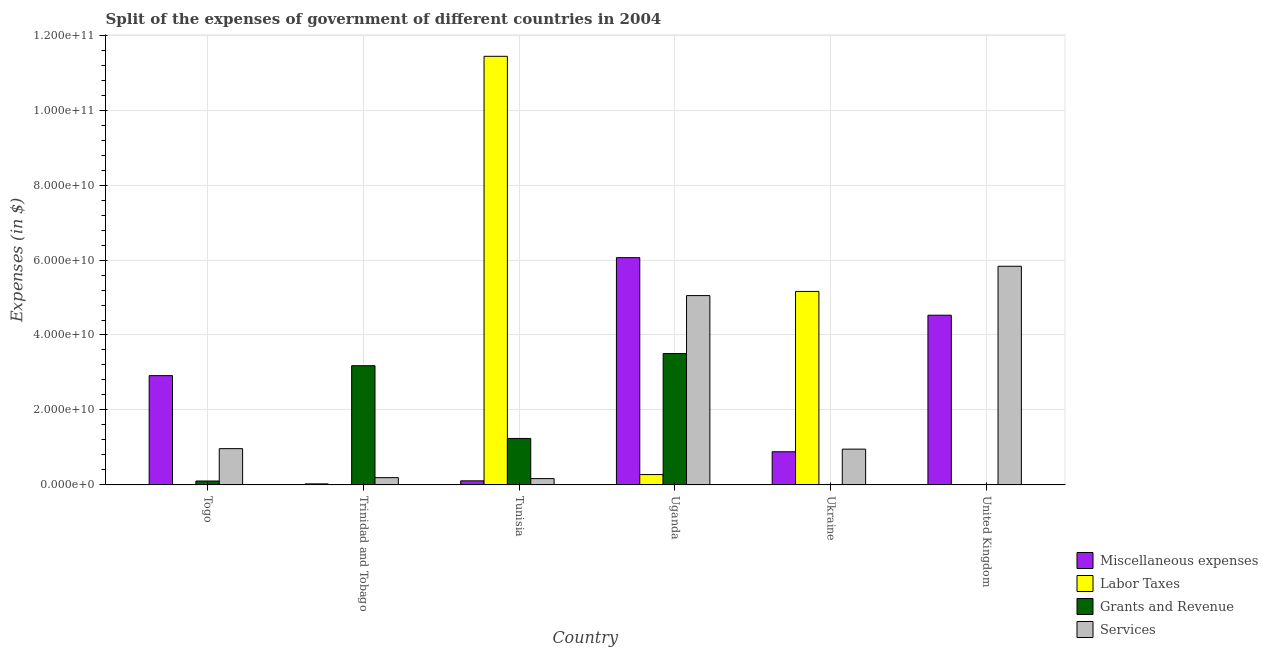How many groups of bars are there?
Offer a very short reply. 6. Are the number of bars per tick equal to the number of legend labels?
Ensure brevity in your answer.  Yes. What is the label of the 6th group of bars from the left?
Your response must be concise. United Kingdom. In how many cases, is the number of bars for a given country not equal to the number of legend labels?
Give a very brief answer. 0. What is the amount spent on grants and revenue in Uganda?
Give a very brief answer. 3.51e+1. Across all countries, what is the maximum amount spent on labor taxes?
Give a very brief answer. 1.14e+11. Across all countries, what is the minimum amount spent on grants and revenue?
Keep it short and to the point. 6.00e+06. In which country was the amount spent on services maximum?
Ensure brevity in your answer.  United Kingdom. In which country was the amount spent on miscellaneous expenses minimum?
Your response must be concise. Trinidad and Tobago. What is the total amount spent on grants and revenue in the graph?
Ensure brevity in your answer.  8.04e+1. What is the difference between the amount spent on labor taxes in Trinidad and Tobago and that in Uganda?
Your answer should be very brief. -2.71e+09. What is the difference between the amount spent on grants and revenue in Uganda and the amount spent on labor taxes in Togo?
Keep it short and to the point. 3.50e+1. What is the average amount spent on services per country?
Offer a very short reply. 2.19e+1. What is the difference between the amount spent on labor taxes and amount spent on miscellaneous expenses in Togo?
Keep it short and to the point. -2.92e+1. In how many countries, is the amount spent on labor taxes greater than 116000000000 $?
Your response must be concise. 0. What is the ratio of the amount spent on grants and revenue in Trinidad and Tobago to that in Tunisia?
Your response must be concise. 2.57. Is the difference between the amount spent on labor taxes in Togo and Tunisia greater than the difference between the amount spent on services in Togo and Tunisia?
Offer a terse response. No. What is the difference between the highest and the second highest amount spent on labor taxes?
Provide a short and direct response. 6.27e+1. What is the difference between the highest and the lowest amount spent on grants and revenue?
Provide a short and direct response. 3.50e+1. Is it the case that in every country, the sum of the amount spent on labor taxes and amount spent on grants and revenue is greater than the sum of amount spent on services and amount spent on miscellaneous expenses?
Give a very brief answer. No. What does the 1st bar from the left in United Kingdom represents?
Offer a terse response. Miscellaneous expenses. What does the 3rd bar from the right in United Kingdom represents?
Your answer should be compact. Labor Taxes. Is it the case that in every country, the sum of the amount spent on miscellaneous expenses and amount spent on labor taxes is greater than the amount spent on grants and revenue?
Your answer should be compact. No. How many countries are there in the graph?
Offer a terse response. 6. What is the difference between two consecutive major ticks on the Y-axis?
Offer a very short reply. 2.00e+1. Are the values on the major ticks of Y-axis written in scientific E-notation?
Provide a succinct answer. Yes. Does the graph contain any zero values?
Your response must be concise. No. Does the graph contain grids?
Keep it short and to the point. Yes. How are the legend labels stacked?
Offer a very short reply. Vertical. What is the title of the graph?
Your answer should be very brief. Split of the expenses of government of different countries in 2004. What is the label or title of the X-axis?
Offer a very short reply. Country. What is the label or title of the Y-axis?
Offer a very short reply. Expenses (in $). What is the Expenses (in $) in Miscellaneous expenses in Togo?
Your response must be concise. 2.92e+1. What is the Expenses (in $) of Labor Taxes in Togo?
Offer a very short reply. 2.50e+06. What is the Expenses (in $) of Grants and Revenue in Togo?
Provide a short and direct response. 1.04e+09. What is the Expenses (in $) in Services in Togo?
Provide a succinct answer. 9.67e+09. What is the Expenses (in $) in Miscellaneous expenses in Trinidad and Tobago?
Ensure brevity in your answer.  2.71e+08. What is the Expenses (in $) of Labor Taxes in Trinidad and Tobago?
Ensure brevity in your answer.  4.07e+07. What is the Expenses (in $) in Grants and Revenue in Trinidad and Tobago?
Your response must be concise. 3.18e+1. What is the Expenses (in $) of Services in Trinidad and Tobago?
Make the answer very short. 1.93e+09. What is the Expenses (in $) in Miscellaneous expenses in Tunisia?
Your answer should be compact. 1.08e+09. What is the Expenses (in $) in Labor Taxes in Tunisia?
Give a very brief answer. 1.14e+11. What is the Expenses (in $) of Grants and Revenue in Tunisia?
Your answer should be compact. 1.24e+1. What is the Expenses (in $) in Services in Tunisia?
Your answer should be compact. 1.68e+09. What is the Expenses (in $) in Miscellaneous expenses in Uganda?
Provide a succinct answer. 6.06e+1. What is the Expenses (in $) in Labor Taxes in Uganda?
Keep it short and to the point. 2.75e+09. What is the Expenses (in $) of Grants and Revenue in Uganda?
Ensure brevity in your answer.  3.51e+1. What is the Expenses (in $) of Services in Uganda?
Keep it short and to the point. 5.05e+1. What is the Expenses (in $) of Miscellaneous expenses in Ukraine?
Ensure brevity in your answer.  8.84e+09. What is the Expenses (in $) of Labor Taxes in Ukraine?
Make the answer very short. 5.16e+1. What is the Expenses (in $) of Grants and Revenue in Ukraine?
Your answer should be compact. 8.76e+07. What is the Expenses (in $) of Services in Ukraine?
Provide a short and direct response. 9.54e+09. What is the Expenses (in $) of Miscellaneous expenses in United Kingdom?
Ensure brevity in your answer.  4.53e+1. What is the Expenses (in $) of Labor Taxes in United Kingdom?
Provide a succinct answer. 1.14e+07. What is the Expenses (in $) in Grants and Revenue in United Kingdom?
Offer a terse response. 6.00e+06. What is the Expenses (in $) of Services in United Kingdom?
Make the answer very short. 5.83e+1. Across all countries, what is the maximum Expenses (in $) in Miscellaneous expenses?
Make the answer very short. 6.06e+1. Across all countries, what is the maximum Expenses (in $) in Labor Taxes?
Your answer should be compact. 1.14e+11. Across all countries, what is the maximum Expenses (in $) of Grants and Revenue?
Your answer should be compact. 3.51e+1. Across all countries, what is the maximum Expenses (in $) in Services?
Your response must be concise. 5.83e+1. Across all countries, what is the minimum Expenses (in $) of Miscellaneous expenses?
Offer a terse response. 2.71e+08. Across all countries, what is the minimum Expenses (in $) of Labor Taxes?
Your answer should be very brief. 2.50e+06. Across all countries, what is the minimum Expenses (in $) of Services?
Provide a short and direct response. 1.68e+09. What is the total Expenses (in $) of Miscellaneous expenses in the graph?
Your answer should be very brief. 1.45e+11. What is the total Expenses (in $) of Labor Taxes in the graph?
Provide a short and direct response. 1.69e+11. What is the total Expenses (in $) in Grants and Revenue in the graph?
Give a very brief answer. 8.04e+1. What is the total Expenses (in $) in Services in the graph?
Keep it short and to the point. 1.32e+11. What is the difference between the Expenses (in $) of Miscellaneous expenses in Togo and that in Trinidad and Tobago?
Your answer should be very brief. 2.89e+1. What is the difference between the Expenses (in $) in Labor Taxes in Togo and that in Trinidad and Tobago?
Give a very brief answer. -3.82e+07. What is the difference between the Expenses (in $) of Grants and Revenue in Togo and that in Trinidad and Tobago?
Keep it short and to the point. -3.08e+1. What is the difference between the Expenses (in $) of Services in Togo and that in Trinidad and Tobago?
Ensure brevity in your answer.  7.74e+09. What is the difference between the Expenses (in $) of Miscellaneous expenses in Togo and that in Tunisia?
Offer a very short reply. 2.81e+1. What is the difference between the Expenses (in $) in Labor Taxes in Togo and that in Tunisia?
Keep it short and to the point. -1.14e+11. What is the difference between the Expenses (in $) of Grants and Revenue in Togo and that in Tunisia?
Your answer should be compact. -1.14e+1. What is the difference between the Expenses (in $) of Services in Togo and that in Tunisia?
Offer a terse response. 7.99e+09. What is the difference between the Expenses (in $) in Miscellaneous expenses in Togo and that in Uganda?
Give a very brief answer. -3.15e+1. What is the difference between the Expenses (in $) in Labor Taxes in Togo and that in Uganda?
Make the answer very short. -2.75e+09. What is the difference between the Expenses (in $) in Grants and Revenue in Togo and that in Uganda?
Offer a very short reply. -3.40e+1. What is the difference between the Expenses (in $) of Services in Togo and that in Uganda?
Offer a terse response. -4.08e+1. What is the difference between the Expenses (in $) in Miscellaneous expenses in Togo and that in Ukraine?
Ensure brevity in your answer.  2.03e+1. What is the difference between the Expenses (in $) of Labor Taxes in Togo and that in Ukraine?
Offer a very short reply. -5.16e+1. What is the difference between the Expenses (in $) of Grants and Revenue in Togo and that in Ukraine?
Your answer should be very brief. 9.50e+08. What is the difference between the Expenses (in $) of Services in Togo and that in Ukraine?
Your answer should be compact. 1.29e+08. What is the difference between the Expenses (in $) of Miscellaneous expenses in Togo and that in United Kingdom?
Keep it short and to the point. -1.61e+1. What is the difference between the Expenses (in $) of Labor Taxes in Togo and that in United Kingdom?
Provide a succinct answer. -8.86e+06. What is the difference between the Expenses (in $) of Grants and Revenue in Togo and that in United Kingdom?
Make the answer very short. 1.03e+09. What is the difference between the Expenses (in $) of Services in Togo and that in United Kingdom?
Offer a terse response. -4.87e+1. What is the difference between the Expenses (in $) of Miscellaneous expenses in Trinidad and Tobago and that in Tunisia?
Make the answer very short. -8.11e+08. What is the difference between the Expenses (in $) of Labor Taxes in Trinidad and Tobago and that in Tunisia?
Provide a short and direct response. -1.14e+11. What is the difference between the Expenses (in $) in Grants and Revenue in Trinidad and Tobago and that in Tunisia?
Ensure brevity in your answer.  1.94e+1. What is the difference between the Expenses (in $) in Services in Trinidad and Tobago and that in Tunisia?
Provide a short and direct response. 2.56e+08. What is the difference between the Expenses (in $) in Miscellaneous expenses in Trinidad and Tobago and that in Uganda?
Give a very brief answer. -6.04e+1. What is the difference between the Expenses (in $) of Labor Taxes in Trinidad and Tobago and that in Uganda?
Your answer should be compact. -2.71e+09. What is the difference between the Expenses (in $) of Grants and Revenue in Trinidad and Tobago and that in Uganda?
Keep it short and to the point. -3.25e+09. What is the difference between the Expenses (in $) of Services in Trinidad and Tobago and that in Uganda?
Ensure brevity in your answer.  -4.86e+1. What is the difference between the Expenses (in $) of Miscellaneous expenses in Trinidad and Tobago and that in Ukraine?
Provide a short and direct response. -8.57e+09. What is the difference between the Expenses (in $) in Labor Taxes in Trinidad and Tobago and that in Ukraine?
Your response must be concise. -5.16e+1. What is the difference between the Expenses (in $) of Grants and Revenue in Trinidad and Tobago and that in Ukraine?
Your answer should be compact. 3.17e+1. What is the difference between the Expenses (in $) in Services in Trinidad and Tobago and that in Ukraine?
Keep it short and to the point. -7.61e+09. What is the difference between the Expenses (in $) of Miscellaneous expenses in Trinidad and Tobago and that in United Kingdom?
Your response must be concise. -4.50e+1. What is the difference between the Expenses (in $) of Labor Taxes in Trinidad and Tobago and that in United Kingdom?
Your answer should be very brief. 2.94e+07. What is the difference between the Expenses (in $) in Grants and Revenue in Trinidad and Tobago and that in United Kingdom?
Provide a succinct answer. 3.18e+1. What is the difference between the Expenses (in $) of Services in Trinidad and Tobago and that in United Kingdom?
Give a very brief answer. -5.64e+1. What is the difference between the Expenses (in $) of Miscellaneous expenses in Tunisia and that in Uganda?
Your answer should be compact. -5.96e+1. What is the difference between the Expenses (in $) in Labor Taxes in Tunisia and that in Uganda?
Your answer should be very brief. 1.12e+11. What is the difference between the Expenses (in $) of Grants and Revenue in Tunisia and that in Uganda?
Your answer should be compact. -2.27e+1. What is the difference between the Expenses (in $) in Services in Tunisia and that in Uganda?
Your answer should be very brief. -4.88e+1. What is the difference between the Expenses (in $) of Miscellaneous expenses in Tunisia and that in Ukraine?
Give a very brief answer. -7.76e+09. What is the difference between the Expenses (in $) in Labor Taxes in Tunisia and that in Ukraine?
Your response must be concise. 6.27e+1. What is the difference between the Expenses (in $) in Grants and Revenue in Tunisia and that in Ukraine?
Provide a short and direct response. 1.23e+1. What is the difference between the Expenses (in $) of Services in Tunisia and that in Ukraine?
Give a very brief answer. -7.86e+09. What is the difference between the Expenses (in $) in Miscellaneous expenses in Tunisia and that in United Kingdom?
Give a very brief answer. -4.42e+1. What is the difference between the Expenses (in $) in Labor Taxes in Tunisia and that in United Kingdom?
Give a very brief answer. 1.14e+11. What is the difference between the Expenses (in $) in Grants and Revenue in Tunisia and that in United Kingdom?
Your response must be concise. 1.24e+1. What is the difference between the Expenses (in $) of Services in Tunisia and that in United Kingdom?
Your answer should be very brief. -5.67e+1. What is the difference between the Expenses (in $) of Miscellaneous expenses in Uganda and that in Ukraine?
Offer a terse response. 5.18e+1. What is the difference between the Expenses (in $) of Labor Taxes in Uganda and that in Ukraine?
Offer a very short reply. -4.89e+1. What is the difference between the Expenses (in $) of Grants and Revenue in Uganda and that in Ukraine?
Your answer should be compact. 3.50e+1. What is the difference between the Expenses (in $) in Services in Uganda and that in Ukraine?
Provide a succinct answer. 4.10e+1. What is the difference between the Expenses (in $) in Miscellaneous expenses in Uganda and that in United Kingdom?
Offer a very short reply. 1.54e+1. What is the difference between the Expenses (in $) in Labor Taxes in Uganda and that in United Kingdom?
Keep it short and to the point. 2.74e+09. What is the difference between the Expenses (in $) in Grants and Revenue in Uganda and that in United Kingdom?
Keep it short and to the point. 3.50e+1. What is the difference between the Expenses (in $) of Services in Uganda and that in United Kingdom?
Ensure brevity in your answer.  -7.82e+09. What is the difference between the Expenses (in $) of Miscellaneous expenses in Ukraine and that in United Kingdom?
Give a very brief answer. -3.64e+1. What is the difference between the Expenses (in $) in Labor Taxes in Ukraine and that in United Kingdom?
Your answer should be very brief. 5.16e+1. What is the difference between the Expenses (in $) of Grants and Revenue in Ukraine and that in United Kingdom?
Provide a short and direct response. 8.16e+07. What is the difference between the Expenses (in $) of Services in Ukraine and that in United Kingdom?
Your answer should be very brief. -4.88e+1. What is the difference between the Expenses (in $) in Miscellaneous expenses in Togo and the Expenses (in $) in Labor Taxes in Trinidad and Tobago?
Your response must be concise. 2.91e+1. What is the difference between the Expenses (in $) in Miscellaneous expenses in Togo and the Expenses (in $) in Grants and Revenue in Trinidad and Tobago?
Offer a terse response. -2.65e+09. What is the difference between the Expenses (in $) in Miscellaneous expenses in Togo and the Expenses (in $) in Services in Trinidad and Tobago?
Your response must be concise. 2.72e+1. What is the difference between the Expenses (in $) of Labor Taxes in Togo and the Expenses (in $) of Grants and Revenue in Trinidad and Tobago?
Keep it short and to the point. -3.18e+1. What is the difference between the Expenses (in $) in Labor Taxes in Togo and the Expenses (in $) in Services in Trinidad and Tobago?
Keep it short and to the point. -1.93e+09. What is the difference between the Expenses (in $) in Grants and Revenue in Togo and the Expenses (in $) in Services in Trinidad and Tobago?
Keep it short and to the point. -8.97e+08. What is the difference between the Expenses (in $) in Miscellaneous expenses in Togo and the Expenses (in $) in Labor Taxes in Tunisia?
Your answer should be very brief. -8.52e+1. What is the difference between the Expenses (in $) in Miscellaneous expenses in Togo and the Expenses (in $) in Grants and Revenue in Tunisia?
Give a very brief answer. 1.68e+1. What is the difference between the Expenses (in $) in Miscellaneous expenses in Togo and the Expenses (in $) in Services in Tunisia?
Ensure brevity in your answer.  2.75e+1. What is the difference between the Expenses (in $) of Labor Taxes in Togo and the Expenses (in $) of Grants and Revenue in Tunisia?
Offer a very short reply. -1.24e+1. What is the difference between the Expenses (in $) in Labor Taxes in Togo and the Expenses (in $) in Services in Tunisia?
Offer a very short reply. -1.68e+09. What is the difference between the Expenses (in $) of Grants and Revenue in Togo and the Expenses (in $) of Services in Tunisia?
Provide a short and direct response. -6.41e+08. What is the difference between the Expenses (in $) of Miscellaneous expenses in Togo and the Expenses (in $) of Labor Taxes in Uganda?
Your answer should be compact. 2.64e+1. What is the difference between the Expenses (in $) in Miscellaneous expenses in Togo and the Expenses (in $) in Grants and Revenue in Uganda?
Provide a succinct answer. -5.89e+09. What is the difference between the Expenses (in $) in Miscellaneous expenses in Togo and the Expenses (in $) in Services in Uganda?
Provide a short and direct response. -2.14e+1. What is the difference between the Expenses (in $) in Labor Taxes in Togo and the Expenses (in $) in Grants and Revenue in Uganda?
Your response must be concise. -3.50e+1. What is the difference between the Expenses (in $) of Labor Taxes in Togo and the Expenses (in $) of Services in Uganda?
Keep it short and to the point. -5.05e+1. What is the difference between the Expenses (in $) in Grants and Revenue in Togo and the Expenses (in $) in Services in Uganda?
Provide a short and direct response. -4.95e+1. What is the difference between the Expenses (in $) of Miscellaneous expenses in Togo and the Expenses (in $) of Labor Taxes in Ukraine?
Give a very brief answer. -2.25e+1. What is the difference between the Expenses (in $) of Miscellaneous expenses in Togo and the Expenses (in $) of Grants and Revenue in Ukraine?
Your answer should be compact. 2.91e+1. What is the difference between the Expenses (in $) in Miscellaneous expenses in Togo and the Expenses (in $) in Services in Ukraine?
Keep it short and to the point. 1.96e+1. What is the difference between the Expenses (in $) in Labor Taxes in Togo and the Expenses (in $) in Grants and Revenue in Ukraine?
Provide a short and direct response. -8.51e+07. What is the difference between the Expenses (in $) in Labor Taxes in Togo and the Expenses (in $) in Services in Ukraine?
Provide a short and direct response. -9.54e+09. What is the difference between the Expenses (in $) of Grants and Revenue in Togo and the Expenses (in $) of Services in Ukraine?
Offer a terse response. -8.51e+09. What is the difference between the Expenses (in $) in Miscellaneous expenses in Togo and the Expenses (in $) in Labor Taxes in United Kingdom?
Provide a succinct answer. 2.91e+1. What is the difference between the Expenses (in $) in Miscellaneous expenses in Togo and the Expenses (in $) in Grants and Revenue in United Kingdom?
Offer a terse response. 2.92e+1. What is the difference between the Expenses (in $) in Miscellaneous expenses in Togo and the Expenses (in $) in Services in United Kingdom?
Your response must be concise. -2.92e+1. What is the difference between the Expenses (in $) in Labor Taxes in Togo and the Expenses (in $) in Grants and Revenue in United Kingdom?
Provide a succinct answer. -3.50e+06. What is the difference between the Expenses (in $) in Labor Taxes in Togo and the Expenses (in $) in Services in United Kingdom?
Provide a succinct answer. -5.83e+1. What is the difference between the Expenses (in $) in Grants and Revenue in Togo and the Expenses (in $) in Services in United Kingdom?
Give a very brief answer. -5.73e+1. What is the difference between the Expenses (in $) in Miscellaneous expenses in Trinidad and Tobago and the Expenses (in $) in Labor Taxes in Tunisia?
Provide a succinct answer. -1.14e+11. What is the difference between the Expenses (in $) of Miscellaneous expenses in Trinidad and Tobago and the Expenses (in $) of Grants and Revenue in Tunisia?
Offer a terse response. -1.21e+1. What is the difference between the Expenses (in $) in Miscellaneous expenses in Trinidad and Tobago and the Expenses (in $) in Services in Tunisia?
Your answer should be compact. -1.41e+09. What is the difference between the Expenses (in $) of Labor Taxes in Trinidad and Tobago and the Expenses (in $) of Grants and Revenue in Tunisia?
Keep it short and to the point. -1.24e+1. What is the difference between the Expenses (in $) of Labor Taxes in Trinidad and Tobago and the Expenses (in $) of Services in Tunisia?
Provide a short and direct response. -1.64e+09. What is the difference between the Expenses (in $) of Grants and Revenue in Trinidad and Tobago and the Expenses (in $) of Services in Tunisia?
Offer a terse response. 3.01e+1. What is the difference between the Expenses (in $) of Miscellaneous expenses in Trinidad and Tobago and the Expenses (in $) of Labor Taxes in Uganda?
Give a very brief answer. -2.48e+09. What is the difference between the Expenses (in $) in Miscellaneous expenses in Trinidad and Tobago and the Expenses (in $) in Grants and Revenue in Uganda?
Provide a short and direct response. -3.48e+1. What is the difference between the Expenses (in $) in Miscellaneous expenses in Trinidad and Tobago and the Expenses (in $) in Services in Uganda?
Your answer should be very brief. -5.02e+1. What is the difference between the Expenses (in $) in Labor Taxes in Trinidad and Tobago and the Expenses (in $) in Grants and Revenue in Uganda?
Make the answer very short. -3.50e+1. What is the difference between the Expenses (in $) in Labor Taxes in Trinidad and Tobago and the Expenses (in $) in Services in Uganda?
Provide a short and direct response. -5.05e+1. What is the difference between the Expenses (in $) in Grants and Revenue in Trinidad and Tobago and the Expenses (in $) in Services in Uganda?
Make the answer very short. -1.87e+1. What is the difference between the Expenses (in $) in Miscellaneous expenses in Trinidad and Tobago and the Expenses (in $) in Labor Taxes in Ukraine?
Give a very brief answer. -5.14e+1. What is the difference between the Expenses (in $) of Miscellaneous expenses in Trinidad and Tobago and the Expenses (in $) of Grants and Revenue in Ukraine?
Make the answer very short. 1.84e+08. What is the difference between the Expenses (in $) of Miscellaneous expenses in Trinidad and Tobago and the Expenses (in $) of Services in Ukraine?
Ensure brevity in your answer.  -9.27e+09. What is the difference between the Expenses (in $) in Labor Taxes in Trinidad and Tobago and the Expenses (in $) in Grants and Revenue in Ukraine?
Keep it short and to the point. -4.69e+07. What is the difference between the Expenses (in $) in Labor Taxes in Trinidad and Tobago and the Expenses (in $) in Services in Ukraine?
Your answer should be very brief. -9.50e+09. What is the difference between the Expenses (in $) in Grants and Revenue in Trinidad and Tobago and the Expenses (in $) in Services in Ukraine?
Ensure brevity in your answer.  2.23e+1. What is the difference between the Expenses (in $) of Miscellaneous expenses in Trinidad and Tobago and the Expenses (in $) of Labor Taxes in United Kingdom?
Keep it short and to the point. 2.60e+08. What is the difference between the Expenses (in $) in Miscellaneous expenses in Trinidad and Tobago and the Expenses (in $) in Grants and Revenue in United Kingdom?
Give a very brief answer. 2.65e+08. What is the difference between the Expenses (in $) of Miscellaneous expenses in Trinidad and Tobago and the Expenses (in $) of Services in United Kingdom?
Your response must be concise. -5.81e+1. What is the difference between the Expenses (in $) in Labor Taxes in Trinidad and Tobago and the Expenses (in $) in Grants and Revenue in United Kingdom?
Make the answer very short. 3.47e+07. What is the difference between the Expenses (in $) of Labor Taxes in Trinidad and Tobago and the Expenses (in $) of Services in United Kingdom?
Make the answer very short. -5.83e+1. What is the difference between the Expenses (in $) of Grants and Revenue in Trinidad and Tobago and the Expenses (in $) of Services in United Kingdom?
Make the answer very short. -2.65e+1. What is the difference between the Expenses (in $) of Miscellaneous expenses in Tunisia and the Expenses (in $) of Labor Taxes in Uganda?
Provide a succinct answer. -1.67e+09. What is the difference between the Expenses (in $) in Miscellaneous expenses in Tunisia and the Expenses (in $) in Grants and Revenue in Uganda?
Your answer should be compact. -3.40e+1. What is the difference between the Expenses (in $) of Miscellaneous expenses in Tunisia and the Expenses (in $) of Services in Uganda?
Give a very brief answer. -4.94e+1. What is the difference between the Expenses (in $) of Labor Taxes in Tunisia and the Expenses (in $) of Grants and Revenue in Uganda?
Make the answer very short. 7.93e+1. What is the difference between the Expenses (in $) in Labor Taxes in Tunisia and the Expenses (in $) in Services in Uganda?
Ensure brevity in your answer.  6.38e+1. What is the difference between the Expenses (in $) in Grants and Revenue in Tunisia and the Expenses (in $) in Services in Uganda?
Your answer should be compact. -3.81e+1. What is the difference between the Expenses (in $) in Miscellaneous expenses in Tunisia and the Expenses (in $) in Labor Taxes in Ukraine?
Make the answer very short. -5.05e+1. What is the difference between the Expenses (in $) in Miscellaneous expenses in Tunisia and the Expenses (in $) in Grants and Revenue in Ukraine?
Give a very brief answer. 9.94e+08. What is the difference between the Expenses (in $) of Miscellaneous expenses in Tunisia and the Expenses (in $) of Services in Ukraine?
Your answer should be compact. -8.46e+09. What is the difference between the Expenses (in $) of Labor Taxes in Tunisia and the Expenses (in $) of Grants and Revenue in Ukraine?
Offer a very short reply. 1.14e+11. What is the difference between the Expenses (in $) in Labor Taxes in Tunisia and the Expenses (in $) in Services in Ukraine?
Give a very brief answer. 1.05e+11. What is the difference between the Expenses (in $) in Grants and Revenue in Tunisia and the Expenses (in $) in Services in Ukraine?
Give a very brief answer. 2.85e+09. What is the difference between the Expenses (in $) of Miscellaneous expenses in Tunisia and the Expenses (in $) of Labor Taxes in United Kingdom?
Offer a very short reply. 1.07e+09. What is the difference between the Expenses (in $) in Miscellaneous expenses in Tunisia and the Expenses (in $) in Grants and Revenue in United Kingdom?
Your response must be concise. 1.08e+09. What is the difference between the Expenses (in $) in Miscellaneous expenses in Tunisia and the Expenses (in $) in Services in United Kingdom?
Offer a terse response. -5.73e+1. What is the difference between the Expenses (in $) of Labor Taxes in Tunisia and the Expenses (in $) of Grants and Revenue in United Kingdom?
Offer a terse response. 1.14e+11. What is the difference between the Expenses (in $) in Labor Taxes in Tunisia and the Expenses (in $) in Services in United Kingdom?
Your answer should be very brief. 5.60e+1. What is the difference between the Expenses (in $) of Grants and Revenue in Tunisia and the Expenses (in $) of Services in United Kingdom?
Ensure brevity in your answer.  -4.59e+1. What is the difference between the Expenses (in $) of Miscellaneous expenses in Uganda and the Expenses (in $) of Labor Taxes in Ukraine?
Provide a short and direct response. 9.01e+09. What is the difference between the Expenses (in $) in Miscellaneous expenses in Uganda and the Expenses (in $) in Grants and Revenue in Ukraine?
Give a very brief answer. 6.06e+1. What is the difference between the Expenses (in $) of Miscellaneous expenses in Uganda and the Expenses (in $) of Services in Ukraine?
Your answer should be compact. 5.11e+1. What is the difference between the Expenses (in $) of Labor Taxes in Uganda and the Expenses (in $) of Grants and Revenue in Ukraine?
Your response must be concise. 2.67e+09. What is the difference between the Expenses (in $) in Labor Taxes in Uganda and the Expenses (in $) in Services in Ukraine?
Your response must be concise. -6.79e+09. What is the difference between the Expenses (in $) of Grants and Revenue in Uganda and the Expenses (in $) of Services in Ukraine?
Provide a short and direct response. 2.55e+1. What is the difference between the Expenses (in $) of Miscellaneous expenses in Uganda and the Expenses (in $) of Labor Taxes in United Kingdom?
Keep it short and to the point. 6.06e+1. What is the difference between the Expenses (in $) of Miscellaneous expenses in Uganda and the Expenses (in $) of Grants and Revenue in United Kingdom?
Ensure brevity in your answer.  6.06e+1. What is the difference between the Expenses (in $) of Miscellaneous expenses in Uganda and the Expenses (in $) of Services in United Kingdom?
Give a very brief answer. 2.30e+09. What is the difference between the Expenses (in $) in Labor Taxes in Uganda and the Expenses (in $) in Grants and Revenue in United Kingdom?
Ensure brevity in your answer.  2.75e+09. What is the difference between the Expenses (in $) in Labor Taxes in Uganda and the Expenses (in $) in Services in United Kingdom?
Your answer should be compact. -5.56e+1. What is the difference between the Expenses (in $) in Grants and Revenue in Uganda and the Expenses (in $) in Services in United Kingdom?
Give a very brief answer. -2.33e+1. What is the difference between the Expenses (in $) of Miscellaneous expenses in Ukraine and the Expenses (in $) of Labor Taxes in United Kingdom?
Your response must be concise. 8.83e+09. What is the difference between the Expenses (in $) in Miscellaneous expenses in Ukraine and the Expenses (in $) in Grants and Revenue in United Kingdom?
Keep it short and to the point. 8.84e+09. What is the difference between the Expenses (in $) of Miscellaneous expenses in Ukraine and the Expenses (in $) of Services in United Kingdom?
Give a very brief answer. -4.95e+1. What is the difference between the Expenses (in $) of Labor Taxes in Ukraine and the Expenses (in $) of Grants and Revenue in United Kingdom?
Ensure brevity in your answer.  5.16e+1. What is the difference between the Expenses (in $) in Labor Taxes in Ukraine and the Expenses (in $) in Services in United Kingdom?
Give a very brief answer. -6.72e+09. What is the difference between the Expenses (in $) of Grants and Revenue in Ukraine and the Expenses (in $) of Services in United Kingdom?
Provide a succinct answer. -5.83e+1. What is the average Expenses (in $) in Miscellaneous expenses per country?
Ensure brevity in your answer.  2.42e+1. What is the average Expenses (in $) in Labor Taxes per country?
Ensure brevity in your answer.  2.81e+1. What is the average Expenses (in $) in Grants and Revenue per country?
Make the answer very short. 1.34e+1. What is the average Expenses (in $) in Services per country?
Make the answer very short. 2.19e+1. What is the difference between the Expenses (in $) in Miscellaneous expenses and Expenses (in $) in Labor Taxes in Togo?
Offer a terse response. 2.92e+1. What is the difference between the Expenses (in $) in Miscellaneous expenses and Expenses (in $) in Grants and Revenue in Togo?
Ensure brevity in your answer.  2.81e+1. What is the difference between the Expenses (in $) of Miscellaneous expenses and Expenses (in $) of Services in Togo?
Offer a terse response. 1.95e+1. What is the difference between the Expenses (in $) of Labor Taxes and Expenses (in $) of Grants and Revenue in Togo?
Your answer should be very brief. -1.04e+09. What is the difference between the Expenses (in $) in Labor Taxes and Expenses (in $) in Services in Togo?
Keep it short and to the point. -9.67e+09. What is the difference between the Expenses (in $) of Grants and Revenue and Expenses (in $) of Services in Togo?
Give a very brief answer. -8.63e+09. What is the difference between the Expenses (in $) of Miscellaneous expenses and Expenses (in $) of Labor Taxes in Trinidad and Tobago?
Provide a succinct answer. 2.30e+08. What is the difference between the Expenses (in $) of Miscellaneous expenses and Expenses (in $) of Grants and Revenue in Trinidad and Tobago?
Provide a succinct answer. -3.15e+1. What is the difference between the Expenses (in $) in Miscellaneous expenses and Expenses (in $) in Services in Trinidad and Tobago?
Make the answer very short. -1.66e+09. What is the difference between the Expenses (in $) in Labor Taxes and Expenses (in $) in Grants and Revenue in Trinidad and Tobago?
Ensure brevity in your answer.  -3.18e+1. What is the difference between the Expenses (in $) in Labor Taxes and Expenses (in $) in Services in Trinidad and Tobago?
Provide a succinct answer. -1.89e+09. What is the difference between the Expenses (in $) in Grants and Revenue and Expenses (in $) in Services in Trinidad and Tobago?
Make the answer very short. 2.99e+1. What is the difference between the Expenses (in $) of Miscellaneous expenses and Expenses (in $) of Labor Taxes in Tunisia?
Your response must be concise. -1.13e+11. What is the difference between the Expenses (in $) in Miscellaneous expenses and Expenses (in $) in Grants and Revenue in Tunisia?
Offer a very short reply. -1.13e+1. What is the difference between the Expenses (in $) in Miscellaneous expenses and Expenses (in $) in Services in Tunisia?
Your answer should be compact. -5.96e+08. What is the difference between the Expenses (in $) in Labor Taxes and Expenses (in $) in Grants and Revenue in Tunisia?
Make the answer very short. 1.02e+11. What is the difference between the Expenses (in $) in Labor Taxes and Expenses (in $) in Services in Tunisia?
Make the answer very short. 1.13e+11. What is the difference between the Expenses (in $) of Grants and Revenue and Expenses (in $) of Services in Tunisia?
Keep it short and to the point. 1.07e+1. What is the difference between the Expenses (in $) in Miscellaneous expenses and Expenses (in $) in Labor Taxes in Uganda?
Offer a terse response. 5.79e+1. What is the difference between the Expenses (in $) in Miscellaneous expenses and Expenses (in $) in Grants and Revenue in Uganda?
Provide a succinct answer. 2.56e+1. What is the difference between the Expenses (in $) of Miscellaneous expenses and Expenses (in $) of Services in Uganda?
Keep it short and to the point. 1.01e+1. What is the difference between the Expenses (in $) in Labor Taxes and Expenses (in $) in Grants and Revenue in Uganda?
Offer a very short reply. -3.23e+1. What is the difference between the Expenses (in $) in Labor Taxes and Expenses (in $) in Services in Uganda?
Offer a terse response. -4.78e+1. What is the difference between the Expenses (in $) of Grants and Revenue and Expenses (in $) of Services in Uganda?
Your response must be concise. -1.55e+1. What is the difference between the Expenses (in $) in Miscellaneous expenses and Expenses (in $) in Labor Taxes in Ukraine?
Your answer should be very brief. -4.28e+1. What is the difference between the Expenses (in $) in Miscellaneous expenses and Expenses (in $) in Grants and Revenue in Ukraine?
Your answer should be compact. 8.76e+09. What is the difference between the Expenses (in $) in Miscellaneous expenses and Expenses (in $) in Services in Ukraine?
Your answer should be compact. -6.99e+08. What is the difference between the Expenses (in $) of Labor Taxes and Expenses (in $) of Grants and Revenue in Ukraine?
Your answer should be very brief. 5.15e+1. What is the difference between the Expenses (in $) in Labor Taxes and Expenses (in $) in Services in Ukraine?
Provide a short and direct response. 4.21e+1. What is the difference between the Expenses (in $) in Grants and Revenue and Expenses (in $) in Services in Ukraine?
Keep it short and to the point. -9.46e+09. What is the difference between the Expenses (in $) of Miscellaneous expenses and Expenses (in $) of Labor Taxes in United Kingdom?
Offer a very short reply. 4.53e+1. What is the difference between the Expenses (in $) of Miscellaneous expenses and Expenses (in $) of Grants and Revenue in United Kingdom?
Your response must be concise. 4.53e+1. What is the difference between the Expenses (in $) in Miscellaneous expenses and Expenses (in $) in Services in United Kingdom?
Your answer should be very brief. -1.31e+1. What is the difference between the Expenses (in $) in Labor Taxes and Expenses (in $) in Grants and Revenue in United Kingdom?
Ensure brevity in your answer.  5.36e+06. What is the difference between the Expenses (in $) in Labor Taxes and Expenses (in $) in Services in United Kingdom?
Give a very brief answer. -5.83e+1. What is the difference between the Expenses (in $) of Grants and Revenue and Expenses (in $) of Services in United Kingdom?
Your answer should be compact. -5.83e+1. What is the ratio of the Expenses (in $) in Miscellaneous expenses in Togo to that in Trinidad and Tobago?
Give a very brief answer. 107.51. What is the ratio of the Expenses (in $) in Labor Taxes in Togo to that in Trinidad and Tobago?
Give a very brief answer. 0.06. What is the ratio of the Expenses (in $) of Grants and Revenue in Togo to that in Trinidad and Tobago?
Ensure brevity in your answer.  0.03. What is the ratio of the Expenses (in $) in Services in Togo to that in Trinidad and Tobago?
Ensure brevity in your answer.  5. What is the ratio of the Expenses (in $) of Miscellaneous expenses in Togo to that in Tunisia?
Offer a very short reply. 26.95. What is the ratio of the Expenses (in $) in Grants and Revenue in Togo to that in Tunisia?
Provide a short and direct response. 0.08. What is the ratio of the Expenses (in $) in Services in Togo to that in Tunisia?
Make the answer very short. 5.76. What is the ratio of the Expenses (in $) of Miscellaneous expenses in Togo to that in Uganda?
Your response must be concise. 0.48. What is the ratio of the Expenses (in $) of Labor Taxes in Togo to that in Uganda?
Keep it short and to the point. 0. What is the ratio of the Expenses (in $) of Grants and Revenue in Togo to that in Uganda?
Your response must be concise. 0.03. What is the ratio of the Expenses (in $) in Services in Togo to that in Uganda?
Provide a short and direct response. 0.19. What is the ratio of the Expenses (in $) in Miscellaneous expenses in Togo to that in Ukraine?
Provide a succinct answer. 3.3. What is the ratio of the Expenses (in $) in Grants and Revenue in Togo to that in Ukraine?
Provide a short and direct response. 11.85. What is the ratio of the Expenses (in $) of Services in Togo to that in Ukraine?
Keep it short and to the point. 1.01. What is the ratio of the Expenses (in $) of Miscellaneous expenses in Togo to that in United Kingdom?
Your answer should be very brief. 0.64. What is the ratio of the Expenses (in $) in Labor Taxes in Togo to that in United Kingdom?
Your response must be concise. 0.22. What is the ratio of the Expenses (in $) in Grants and Revenue in Togo to that in United Kingdom?
Your answer should be compact. 172.95. What is the ratio of the Expenses (in $) of Services in Togo to that in United Kingdom?
Keep it short and to the point. 0.17. What is the ratio of the Expenses (in $) in Miscellaneous expenses in Trinidad and Tobago to that in Tunisia?
Offer a very short reply. 0.25. What is the ratio of the Expenses (in $) in Grants and Revenue in Trinidad and Tobago to that in Tunisia?
Make the answer very short. 2.57. What is the ratio of the Expenses (in $) in Services in Trinidad and Tobago to that in Tunisia?
Your response must be concise. 1.15. What is the ratio of the Expenses (in $) in Miscellaneous expenses in Trinidad and Tobago to that in Uganda?
Offer a very short reply. 0. What is the ratio of the Expenses (in $) of Labor Taxes in Trinidad and Tobago to that in Uganda?
Ensure brevity in your answer.  0.01. What is the ratio of the Expenses (in $) of Grants and Revenue in Trinidad and Tobago to that in Uganda?
Make the answer very short. 0.91. What is the ratio of the Expenses (in $) of Services in Trinidad and Tobago to that in Uganda?
Keep it short and to the point. 0.04. What is the ratio of the Expenses (in $) of Miscellaneous expenses in Trinidad and Tobago to that in Ukraine?
Provide a short and direct response. 0.03. What is the ratio of the Expenses (in $) of Labor Taxes in Trinidad and Tobago to that in Ukraine?
Keep it short and to the point. 0. What is the ratio of the Expenses (in $) in Grants and Revenue in Trinidad and Tobago to that in Ukraine?
Offer a very short reply. 363.07. What is the ratio of the Expenses (in $) of Services in Trinidad and Tobago to that in Ukraine?
Your answer should be compact. 0.2. What is the ratio of the Expenses (in $) of Miscellaneous expenses in Trinidad and Tobago to that in United Kingdom?
Offer a very short reply. 0.01. What is the ratio of the Expenses (in $) of Labor Taxes in Trinidad and Tobago to that in United Kingdom?
Make the answer very short. 3.59. What is the ratio of the Expenses (in $) in Grants and Revenue in Trinidad and Tobago to that in United Kingdom?
Offer a terse response. 5300.83. What is the ratio of the Expenses (in $) of Services in Trinidad and Tobago to that in United Kingdom?
Make the answer very short. 0.03. What is the ratio of the Expenses (in $) in Miscellaneous expenses in Tunisia to that in Uganda?
Offer a very short reply. 0.02. What is the ratio of the Expenses (in $) of Labor Taxes in Tunisia to that in Uganda?
Make the answer very short. 41.52. What is the ratio of the Expenses (in $) of Grants and Revenue in Tunisia to that in Uganda?
Your response must be concise. 0.35. What is the ratio of the Expenses (in $) of Services in Tunisia to that in Uganda?
Offer a terse response. 0.03. What is the ratio of the Expenses (in $) in Miscellaneous expenses in Tunisia to that in Ukraine?
Provide a succinct answer. 0.12. What is the ratio of the Expenses (in $) in Labor Taxes in Tunisia to that in Ukraine?
Keep it short and to the point. 2.22. What is the ratio of the Expenses (in $) of Grants and Revenue in Tunisia to that in Ukraine?
Provide a succinct answer. 141.52. What is the ratio of the Expenses (in $) of Services in Tunisia to that in Ukraine?
Provide a succinct answer. 0.18. What is the ratio of the Expenses (in $) in Miscellaneous expenses in Tunisia to that in United Kingdom?
Offer a very short reply. 0.02. What is the ratio of the Expenses (in $) in Labor Taxes in Tunisia to that in United Kingdom?
Your answer should be compact. 1.01e+04. What is the ratio of the Expenses (in $) of Grants and Revenue in Tunisia to that in United Kingdom?
Keep it short and to the point. 2066.17. What is the ratio of the Expenses (in $) of Services in Tunisia to that in United Kingdom?
Your answer should be compact. 0.03. What is the ratio of the Expenses (in $) in Miscellaneous expenses in Uganda to that in Ukraine?
Keep it short and to the point. 6.86. What is the ratio of the Expenses (in $) in Labor Taxes in Uganda to that in Ukraine?
Provide a short and direct response. 0.05. What is the ratio of the Expenses (in $) in Grants and Revenue in Uganda to that in Ukraine?
Provide a short and direct response. 400.13. What is the ratio of the Expenses (in $) in Services in Uganda to that in Ukraine?
Keep it short and to the point. 5.29. What is the ratio of the Expenses (in $) of Miscellaneous expenses in Uganda to that in United Kingdom?
Provide a succinct answer. 1.34. What is the ratio of the Expenses (in $) in Labor Taxes in Uganda to that in United Kingdom?
Make the answer very short. 242.6. What is the ratio of the Expenses (in $) in Grants and Revenue in Uganda to that in United Kingdom?
Ensure brevity in your answer.  5841.83. What is the ratio of the Expenses (in $) of Services in Uganda to that in United Kingdom?
Keep it short and to the point. 0.87. What is the ratio of the Expenses (in $) of Miscellaneous expenses in Ukraine to that in United Kingdom?
Offer a very short reply. 0.2. What is the ratio of the Expenses (in $) in Labor Taxes in Ukraine to that in United Kingdom?
Your answer should be compact. 4546.54. What is the ratio of the Expenses (in $) in Services in Ukraine to that in United Kingdom?
Your answer should be very brief. 0.16. What is the difference between the highest and the second highest Expenses (in $) of Miscellaneous expenses?
Provide a short and direct response. 1.54e+1. What is the difference between the highest and the second highest Expenses (in $) in Labor Taxes?
Give a very brief answer. 6.27e+1. What is the difference between the highest and the second highest Expenses (in $) of Grants and Revenue?
Provide a short and direct response. 3.25e+09. What is the difference between the highest and the second highest Expenses (in $) of Services?
Ensure brevity in your answer.  7.82e+09. What is the difference between the highest and the lowest Expenses (in $) in Miscellaneous expenses?
Ensure brevity in your answer.  6.04e+1. What is the difference between the highest and the lowest Expenses (in $) of Labor Taxes?
Provide a short and direct response. 1.14e+11. What is the difference between the highest and the lowest Expenses (in $) in Grants and Revenue?
Offer a terse response. 3.50e+1. What is the difference between the highest and the lowest Expenses (in $) in Services?
Your answer should be very brief. 5.67e+1. 